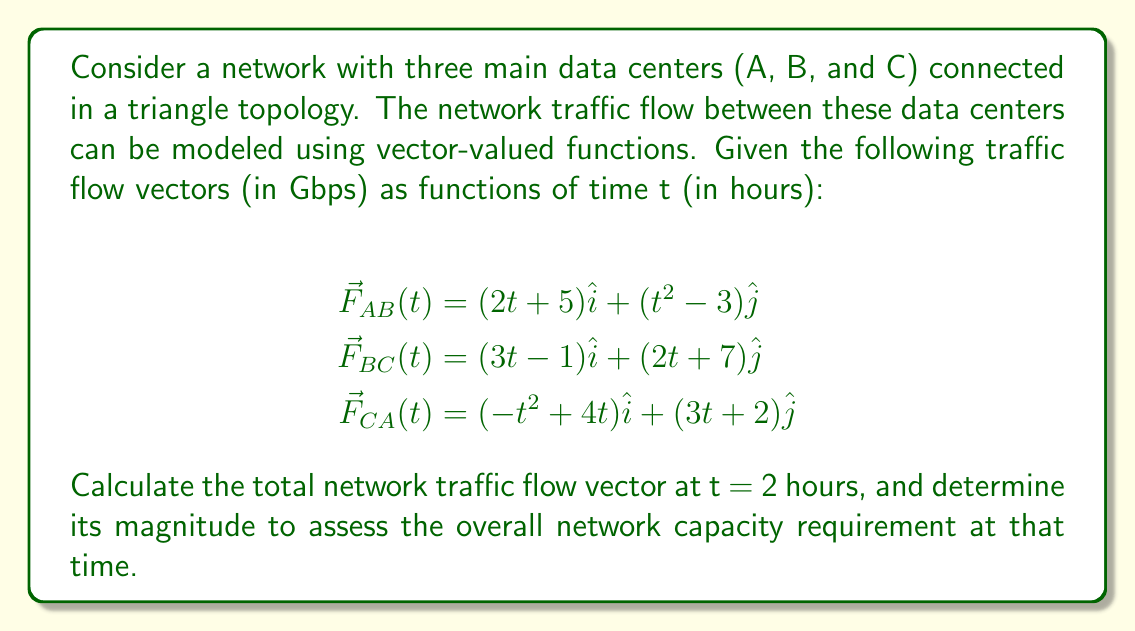Teach me how to tackle this problem. To solve this problem, we'll follow these steps:

1. Evaluate each vector-valued function at t = 2 hours.
2. Sum up the resulting vectors to get the total network traffic flow vector.
3. Calculate the magnitude of the total vector.

Step 1: Evaluate each function at t = 2

For $\vec{F}_{AB}(2)$:
$$\vec{F}_{AB}(2) = (2(2) + 5)\hat{i} + (2^2 - 3)\hat{j} = 9\hat{i} + 1\hat{j}$$

For $\vec{F}_{BC}(2)$:
$$\vec{F}_{BC}(2) = (3(2) - 1)\hat{i} + (2(2) + 7)\hat{j} = 5\hat{i} + 11\hat{j}$$

For $\vec{F}_{CA}(2)$:
$$\vec{F}_{CA}(2) = (-2^2 + 4(2))\hat{i} + (3(2) + 2)\hat{j} = 4\hat{i} + 8\hat{j}$$

Step 2: Sum up the vectors

Total network traffic flow vector $\vec{F}_{total}(2)$:
$$\vec{F}_{total}(2) = \vec{F}_{AB}(2) + \vec{F}_{BC}(2) + \vec{F}_{CA}(2)$$
$$= (9\hat{i} + 1\hat{j}) + (5\hat{i} + 11\hat{j}) + (4\hat{i} + 8\hat{j})$$
$$= 18\hat{i} + 20\hat{j}$$

Step 3: Calculate the magnitude

The magnitude of the total vector is given by:
$$\|\vec{F}_{total}(2)\| = \sqrt{18^2 + 20^2}$$
$$= \sqrt{324 + 400}$$
$$= \sqrt{724}$$
$$\approx 26.91 \text{ Gbps}$$

This magnitude represents the overall network capacity requirement at t = 2 hours.
Answer: The total network traffic flow vector at t = 2 hours is $18\hat{i} + 20\hat{j}$ Gbps, and its magnitude (overall network capacity requirement) is approximately 26.91 Gbps. 